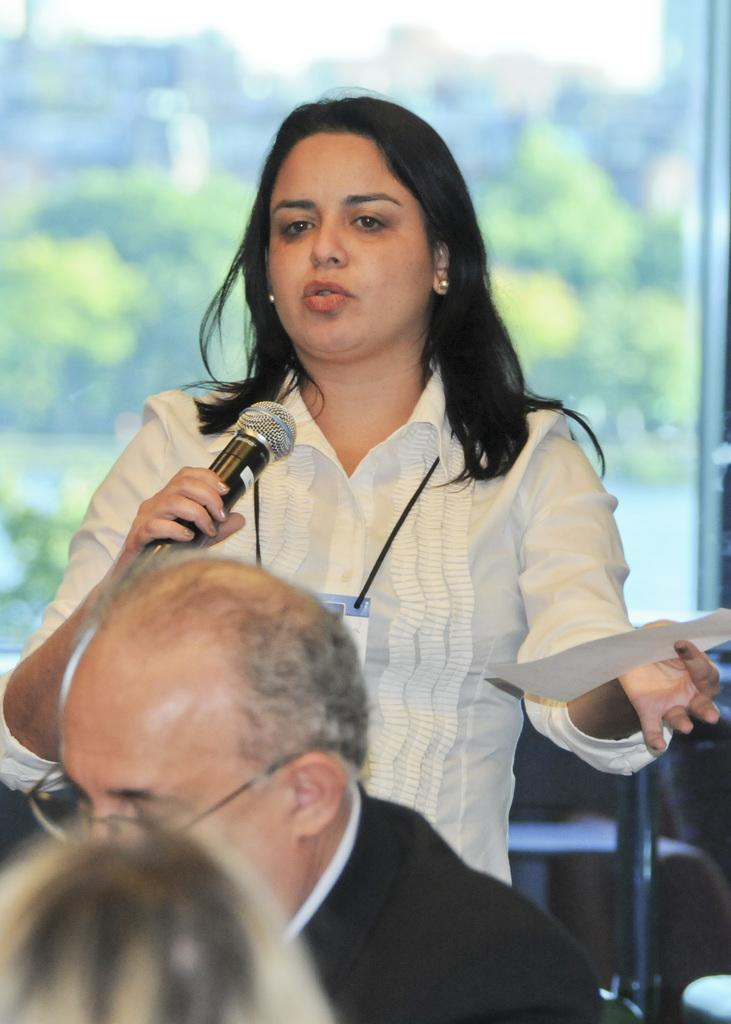Who is the main subject in the image? There is a woman in the image. What is the woman holding in her hands? The woman is holding a mic and a paper. Who is present in front of the woman? There are people in front of the woman. What can be seen in the background of the image? There are trees in the background of the image. How would you describe the background's appearance? The background of the image is blurry. What type of rhythm can be heard from the chickens in the image? There are no chickens present in the image, so there is no rhythm to be heard from them. How many books can be seen on the table in the image? There is no table or books visible in the image. 